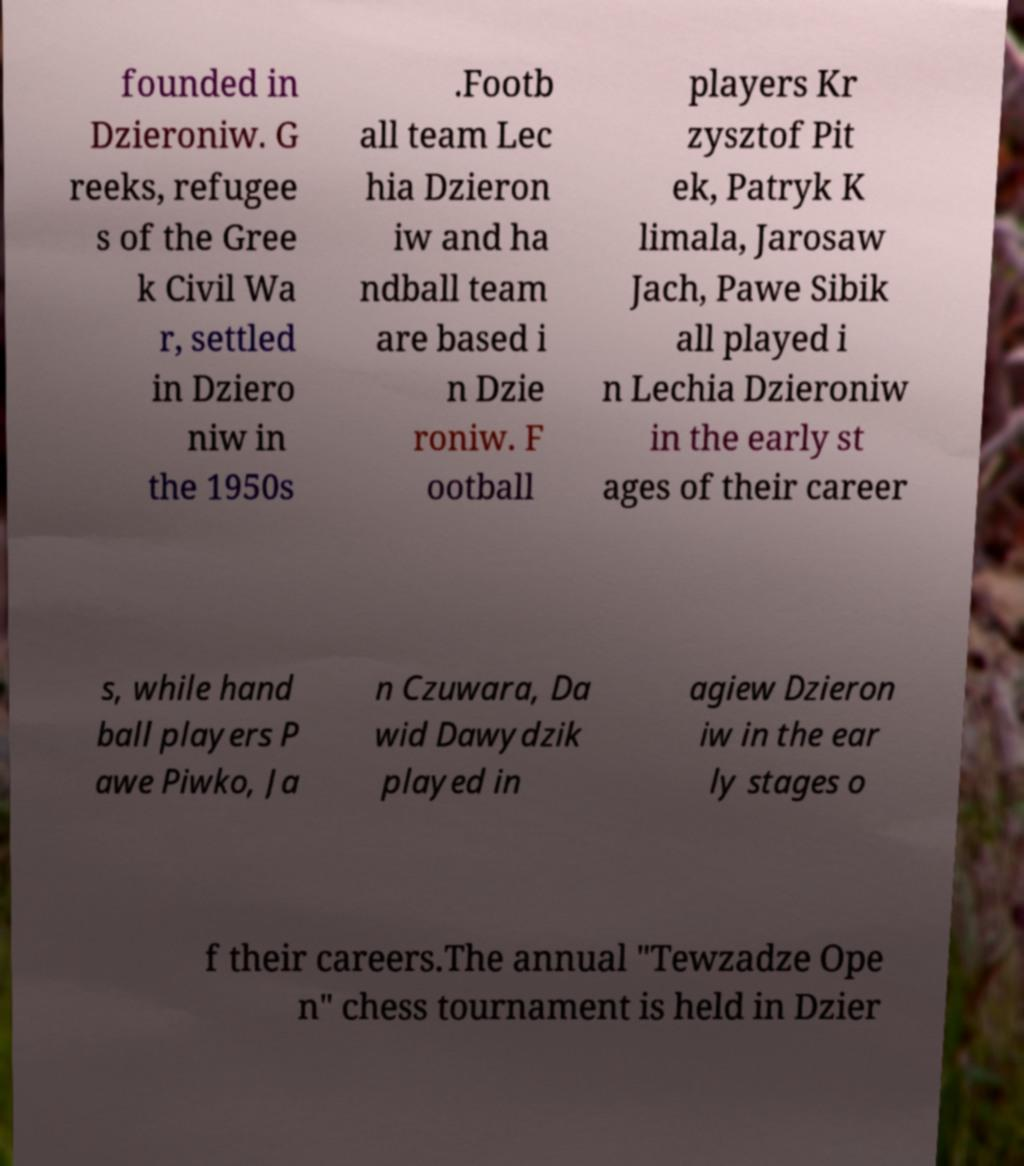I need the written content from this picture converted into text. Can you do that? founded in Dzieroniw. G reeks, refugee s of the Gree k Civil Wa r, settled in Dziero niw in the 1950s .Footb all team Lec hia Dzieron iw and ha ndball team are based i n Dzie roniw. F ootball players Kr zysztof Pit ek, Patryk K limala, Jarosaw Jach, Pawe Sibik all played i n Lechia Dzieroniw in the early st ages of their career s, while hand ball players P awe Piwko, Ja n Czuwara, Da wid Dawydzik played in agiew Dzieron iw in the ear ly stages o f their careers.The annual "Tewzadze Ope n" chess tournament is held in Dzier 